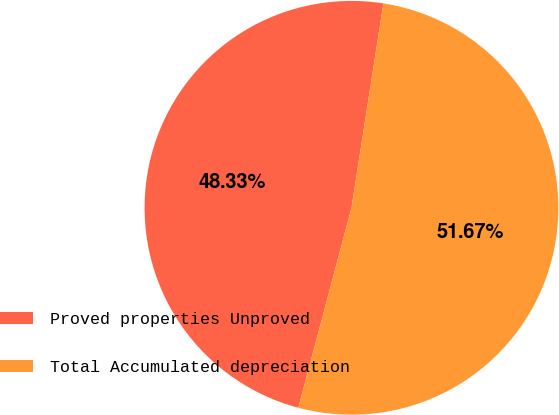<chart> <loc_0><loc_0><loc_500><loc_500><pie_chart><fcel>Proved properties Unproved<fcel>Total Accumulated depreciation<nl><fcel>48.33%<fcel>51.67%<nl></chart> 